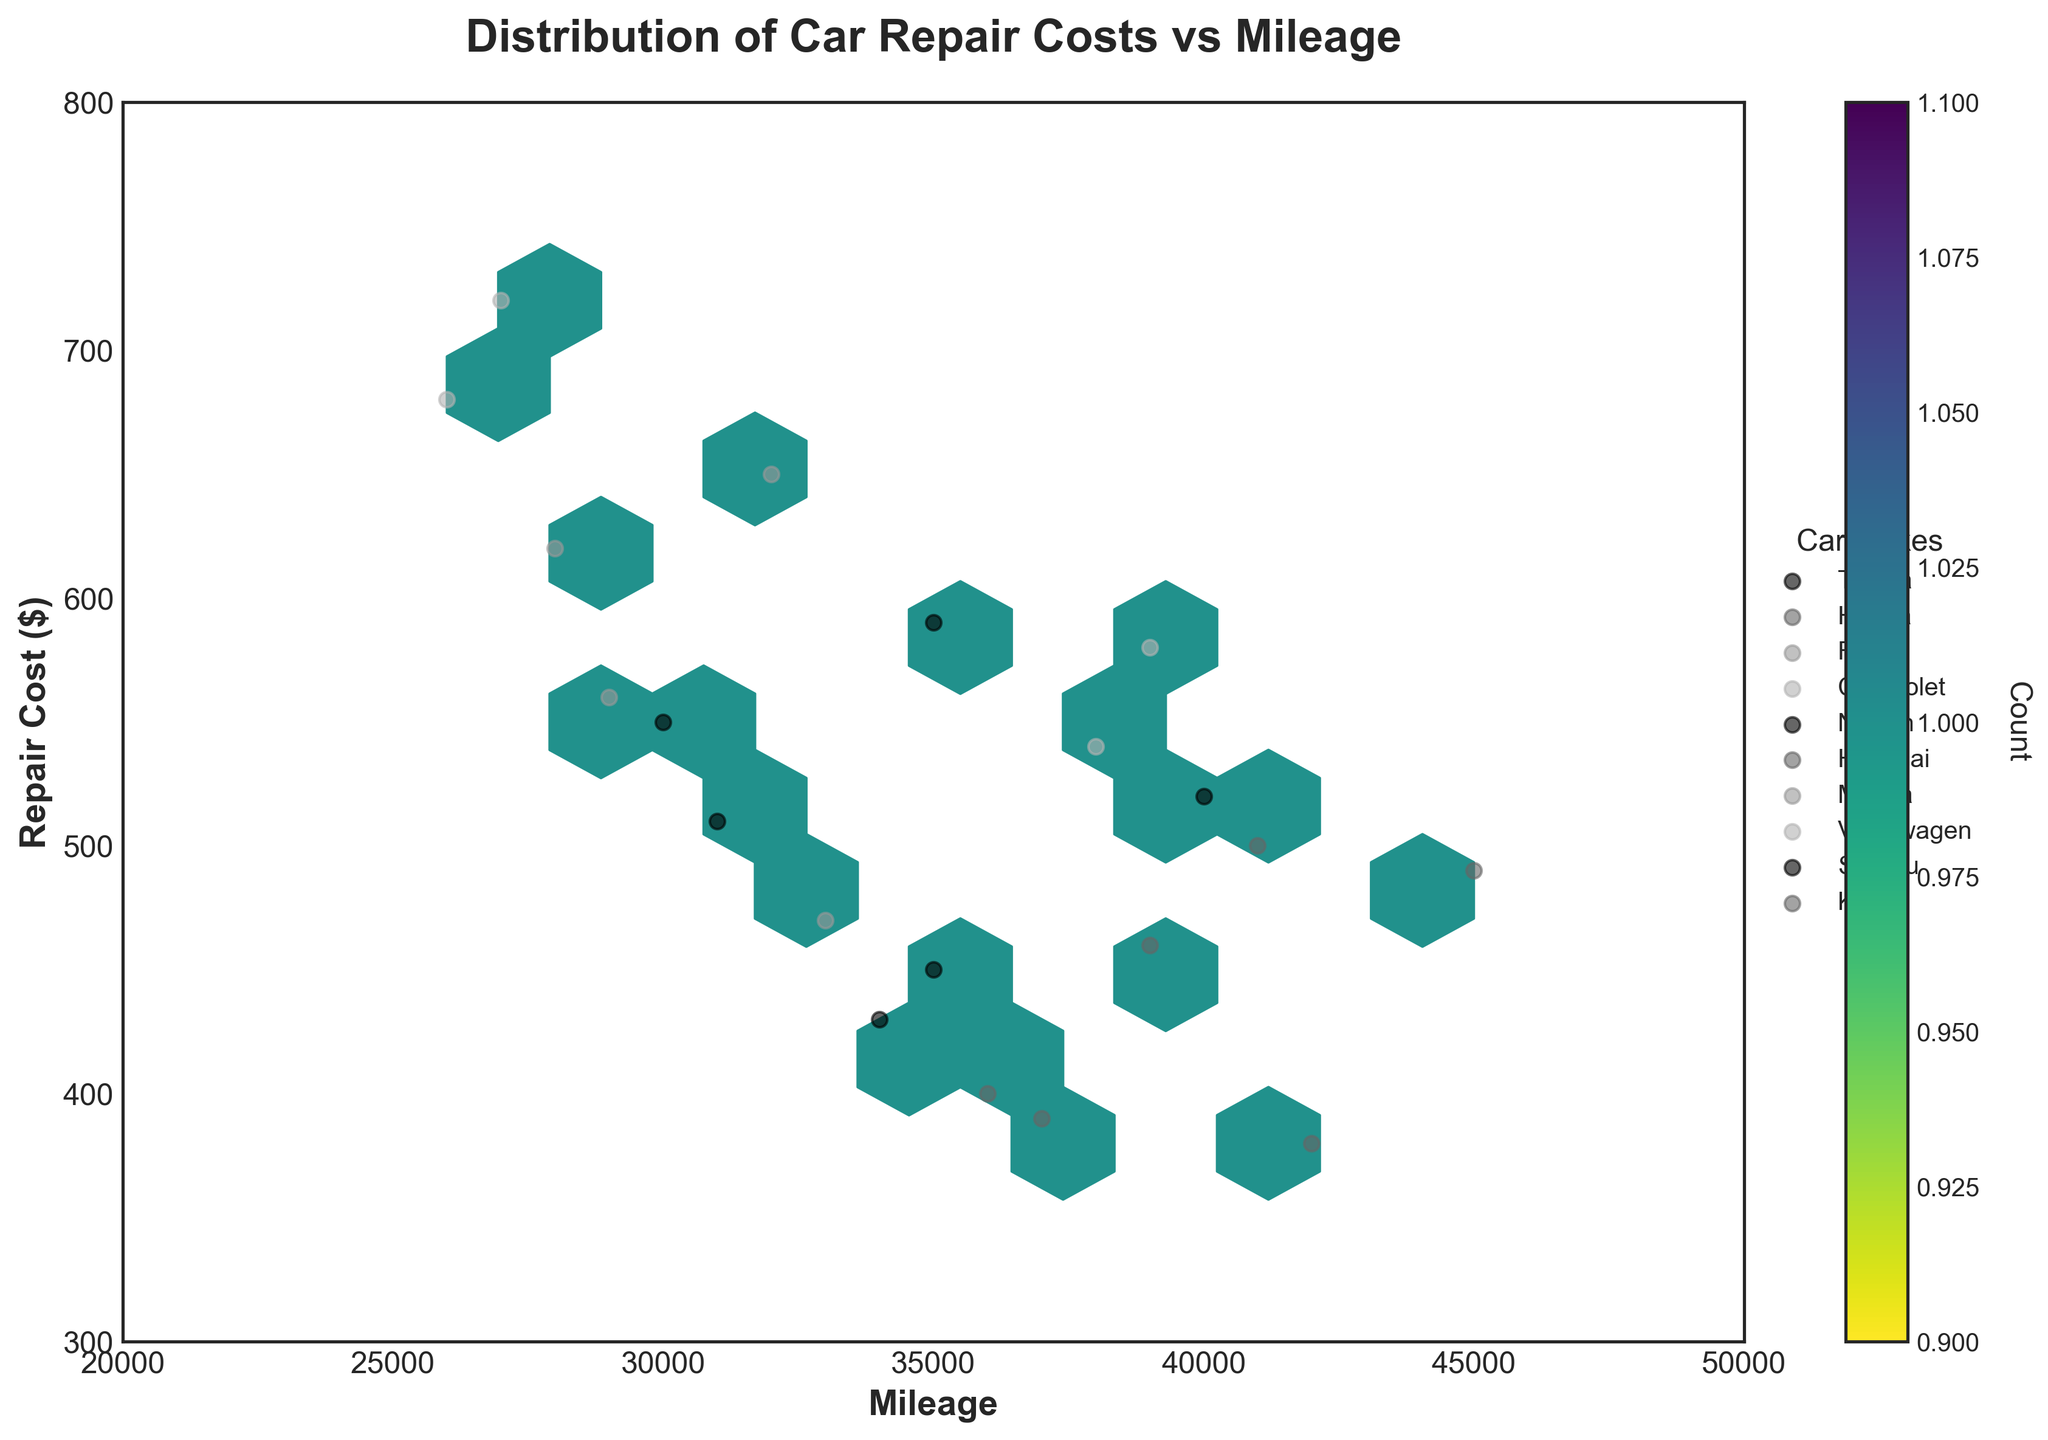What's the title of the plot? The title of the plot is usually displayed at the top and provides a summary of what the plot represents. In this case, the title reads "Distribution of Car Repair Costs vs Mileage".
Answer: Distribution of Car Repair Costs vs Mileage What are the labels of the x-axis and y-axis? The x-axis label represents the horizontal measurement, while the y-axis label represents the vertical measurement. The labels are given as "Mileage" for the x-axis and "Repair Cost ($)" for the y-axis.
Answer: Mileage and Repair Cost ($) Which car make has the highest repair cost? By observing the scatter points marked for each car make, we can see that the Volkswagen Passat has the highest repair cost at around $720.
Answer: Volkswagen Passat How many color bins (levels of density) are used in the Hexbin Plot? The Hexbin Plot uses different shades of color to represent density levels, which can be identified by the color bar. There are 10 levels of density, as indicated by the color bar on the side.
Answer: 10 What is the range of mileages displayed on the x-axis? The x-axis range can be determined by identifying the minimum and maximum values depicted on the axis. The range goes from 20000 to 50000 miles.
Answer: 20000 to 50000 miles What's the most common range of repair costs and mileages according to the hexbin plot? The most common areas are represented by the densest hexagons. By looking at the darkest shades, the most common repair costs range from $450 to $600 and mileages from 30000 to 40000 miles.
Answer: $450-$600 and 30000-40000 miles Which car make has the lowest repair cost? By looking at the scatter points for each car make, Hyundai Elantra appears to have one of the lowest repair costs, approximately $390.
Answer: Hyundai Elantra Are there any makes with multiple models and how do their repair costs compare? Toyota, Honda, Ford, Chevrolet, Nissan, Hyundai, Mazda, Volkswagen, Subaru, and Kia have multiple models. By comparing the scatter points for each make, we can evaluate their repair costs. For example, Toyota Corolla and Camry have similar costs around $450 and $520, respectively.
Answer: Yes, and the costs are similar or vary slightly Which make appears to have the most uniform repair costs regardless of mileage? By comparing the scatter plots, Subaru appears to have relatively uniform repair costs (around $550-$590) regardless of mileage.
Answer: Subaru Based on the plot, what’s a rough estimation of repair costs for a car with 35000 miles? Observing the vertical scatter distribution, cars with around 35000 miles generally have repair costs between $450 and $600, with some makes falling outside this range.
Answer: $450-$600 